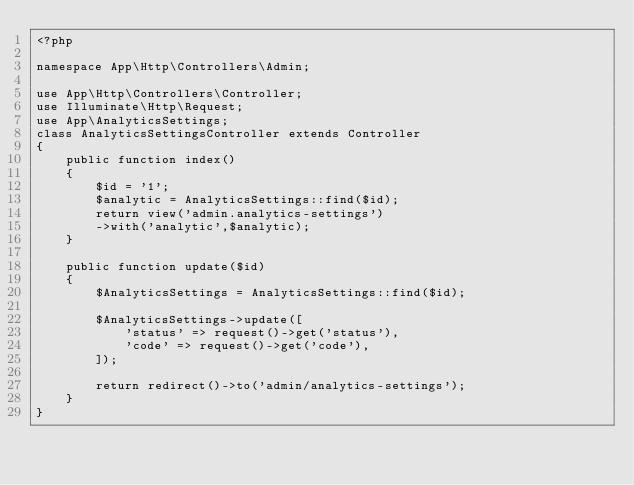<code> <loc_0><loc_0><loc_500><loc_500><_PHP_><?php

namespace App\Http\Controllers\Admin;

use App\Http\Controllers\Controller;
use Illuminate\Http\Request;
use App\AnalyticsSettings;
class AnalyticsSettingsController extends Controller
{
    public function index()
    {
    	$id = '1';
    	$analytic = AnalyticsSettings::find($id);
    	return view('admin.analytics-settings')
    	->with('analytic',$analytic);
    }

    public function update($id)
    {
    	$AnalyticsSettings = AnalyticsSettings::find($id);
    	
        $AnalyticsSettings->update([
            'status' => request()->get('status'),
            'code' => request()->get('code'),
        ]);

        return redirect()->to('admin/analytics-settings');
    }
}
</code> 